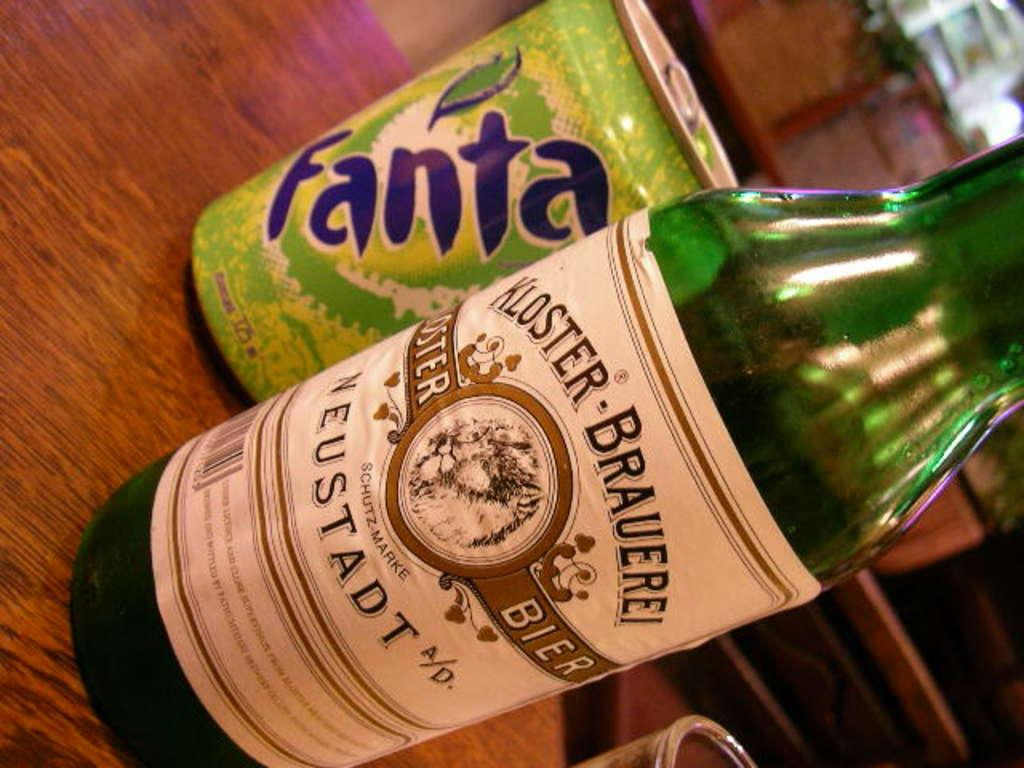<image>
Summarize the visual content of the image. A green can of Fanta sits behind a bottle of Bier. 